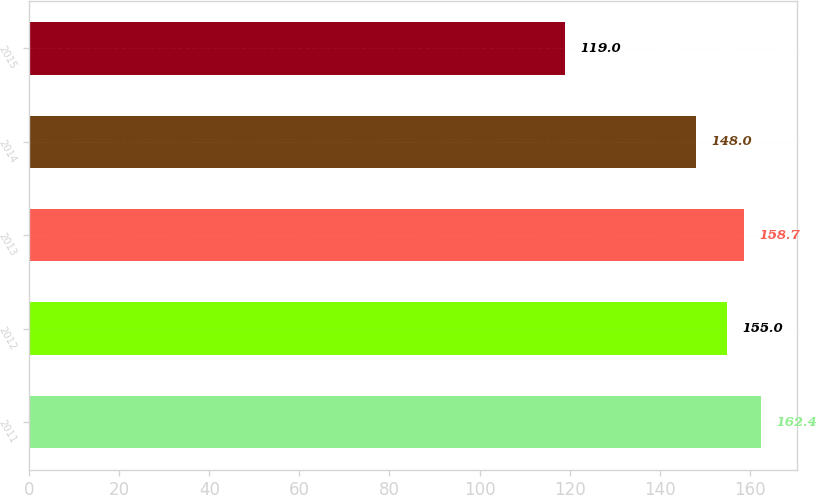Convert chart to OTSL. <chart><loc_0><loc_0><loc_500><loc_500><bar_chart><fcel>2011<fcel>2012<fcel>2013<fcel>2014<fcel>2015<nl><fcel>162.4<fcel>155<fcel>158.7<fcel>148<fcel>119<nl></chart> 